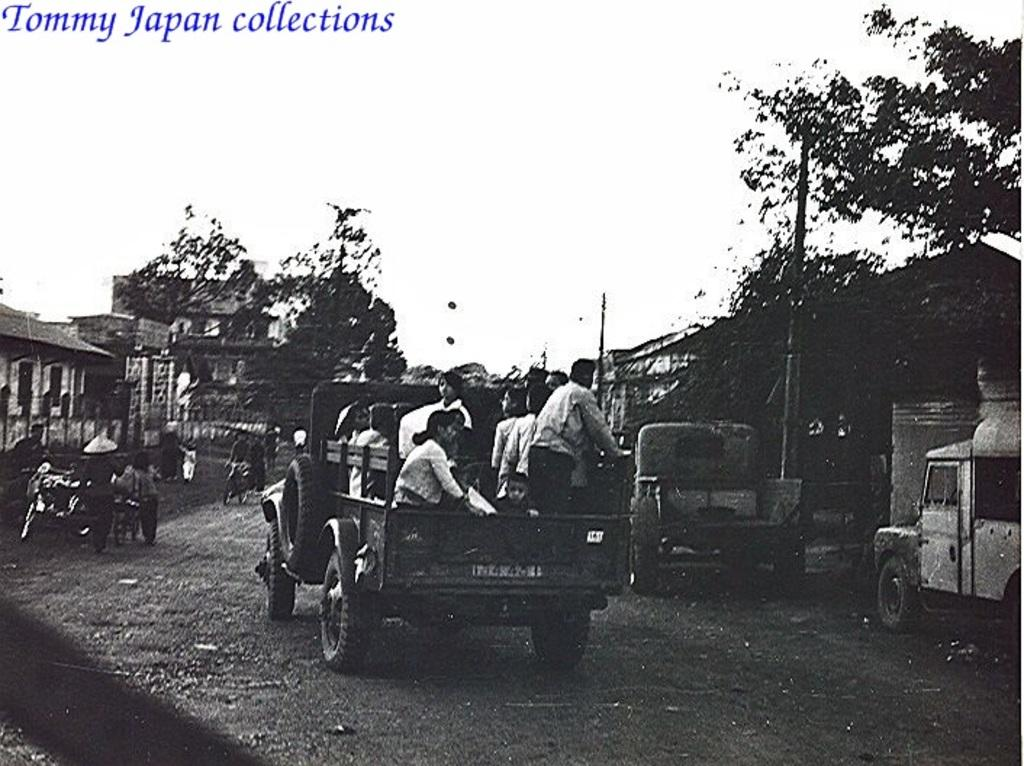What is the color scheme of the image? The image is black and white. What can be seen in the center of the image? There are trees, buildings, poles, and vehicles on the road in the center of the image. Are there any people visible in the image? Yes, there are people sitting in the vehicles. What type of pest can be seen crawling on the branch in the image? There is no branch or pest present in the image. 